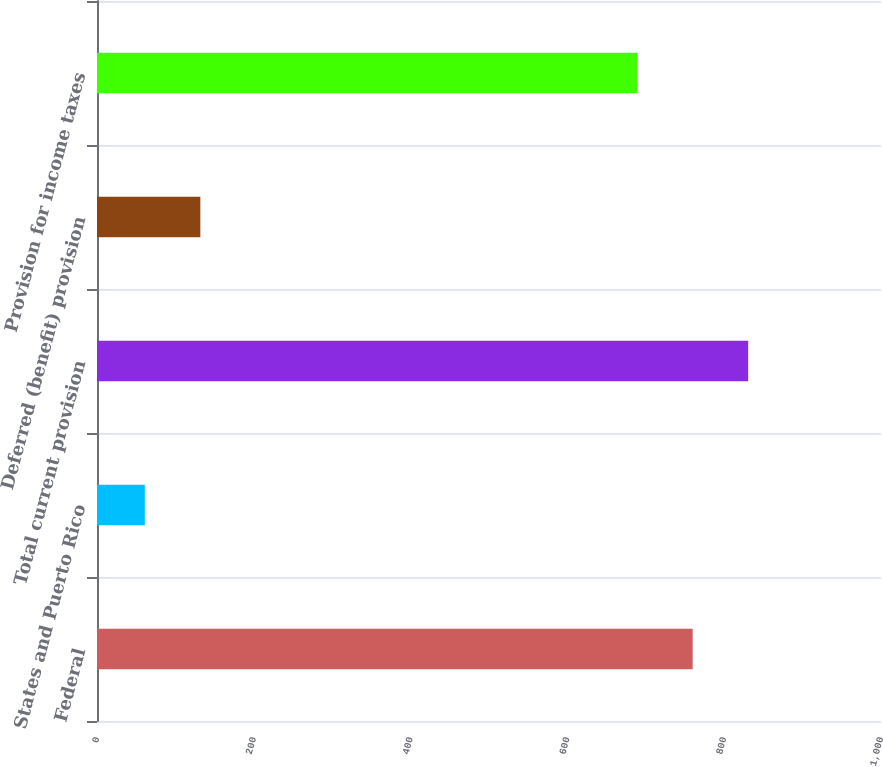Convert chart to OTSL. <chart><loc_0><loc_0><loc_500><loc_500><bar_chart><fcel>Federal<fcel>States and Puerto Rico<fcel>Total current provision<fcel>Deferred (benefit) provision<fcel>Provision for income taxes<nl><fcel>759.8<fcel>61<fcel>830.6<fcel>131.8<fcel>689<nl></chart> 